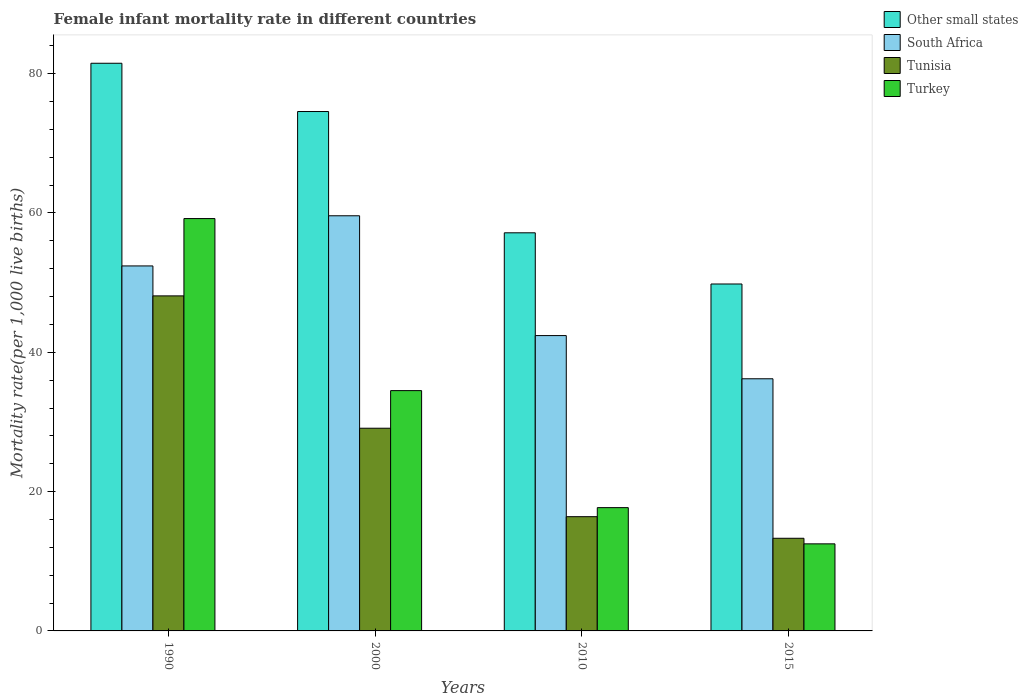How many different coloured bars are there?
Provide a succinct answer. 4. How many groups of bars are there?
Your response must be concise. 4. Are the number of bars on each tick of the X-axis equal?
Your answer should be compact. Yes. How many bars are there on the 3rd tick from the right?
Keep it short and to the point. 4. What is the female infant mortality rate in South Africa in 2015?
Keep it short and to the point. 36.2. Across all years, what is the maximum female infant mortality rate in Other small states?
Your answer should be compact. 81.5. Across all years, what is the minimum female infant mortality rate in South Africa?
Your answer should be very brief. 36.2. In which year was the female infant mortality rate in South Africa maximum?
Provide a succinct answer. 2000. In which year was the female infant mortality rate in South Africa minimum?
Your response must be concise. 2015. What is the total female infant mortality rate in Turkey in the graph?
Your response must be concise. 123.9. What is the difference between the female infant mortality rate in South Africa in 2000 and that in 2015?
Give a very brief answer. 23.4. What is the difference between the female infant mortality rate in South Africa in 2010 and the female infant mortality rate in Turkey in 2015?
Your answer should be compact. 29.9. What is the average female infant mortality rate in Other small states per year?
Make the answer very short. 65.76. In the year 2010, what is the difference between the female infant mortality rate in Turkey and female infant mortality rate in South Africa?
Offer a terse response. -24.7. What is the ratio of the female infant mortality rate in Other small states in 2010 to that in 2015?
Make the answer very short. 1.15. Is the female infant mortality rate in South Africa in 2000 less than that in 2010?
Offer a very short reply. No. What is the difference between the highest and the second highest female infant mortality rate in South Africa?
Offer a terse response. 7.2. What is the difference between the highest and the lowest female infant mortality rate in Tunisia?
Offer a terse response. 34.8. Is it the case that in every year, the sum of the female infant mortality rate in Other small states and female infant mortality rate in Tunisia is greater than the sum of female infant mortality rate in South Africa and female infant mortality rate in Turkey?
Provide a short and direct response. No. What does the 2nd bar from the left in 2015 represents?
Give a very brief answer. South Africa. What does the 1st bar from the right in 1990 represents?
Provide a short and direct response. Turkey. Is it the case that in every year, the sum of the female infant mortality rate in South Africa and female infant mortality rate in Other small states is greater than the female infant mortality rate in Turkey?
Your response must be concise. Yes. How many bars are there?
Provide a short and direct response. 16. Are all the bars in the graph horizontal?
Your answer should be very brief. No. How many years are there in the graph?
Keep it short and to the point. 4. Does the graph contain grids?
Provide a succinct answer. No. Where does the legend appear in the graph?
Provide a short and direct response. Top right. What is the title of the graph?
Provide a short and direct response. Female infant mortality rate in different countries. Does "Thailand" appear as one of the legend labels in the graph?
Give a very brief answer. No. What is the label or title of the Y-axis?
Offer a very short reply. Mortality rate(per 1,0 live births). What is the Mortality rate(per 1,000 live births) in Other small states in 1990?
Your answer should be compact. 81.5. What is the Mortality rate(per 1,000 live births) of South Africa in 1990?
Provide a succinct answer. 52.4. What is the Mortality rate(per 1,000 live births) in Tunisia in 1990?
Keep it short and to the point. 48.1. What is the Mortality rate(per 1,000 live births) of Turkey in 1990?
Provide a short and direct response. 59.2. What is the Mortality rate(per 1,000 live births) in Other small states in 2000?
Provide a short and direct response. 74.57. What is the Mortality rate(per 1,000 live births) of South Africa in 2000?
Provide a succinct answer. 59.6. What is the Mortality rate(per 1,000 live births) of Tunisia in 2000?
Give a very brief answer. 29.1. What is the Mortality rate(per 1,000 live births) in Turkey in 2000?
Provide a short and direct response. 34.5. What is the Mortality rate(per 1,000 live births) in Other small states in 2010?
Provide a succinct answer. 57.16. What is the Mortality rate(per 1,000 live births) of South Africa in 2010?
Your response must be concise. 42.4. What is the Mortality rate(per 1,000 live births) in Tunisia in 2010?
Provide a succinct answer. 16.4. What is the Mortality rate(per 1,000 live births) of Other small states in 2015?
Provide a succinct answer. 49.81. What is the Mortality rate(per 1,000 live births) of South Africa in 2015?
Provide a succinct answer. 36.2. What is the Mortality rate(per 1,000 live births) of Turkey in 2015?
Offer a terse response. 12.5. Across all years, what is the maximum Mortality rate(per 1,000 live births) of Other small states?
Your response must be concise. 81.5. Across all years, what is the maximum Mortality rate(per 1,000 live births) of South Africa?
Offer a terse response. 59.6. Across all years, what is the maximum Mortality rate(per 1,000 live births) of Tunisia?
Your answer should be compact. 48.1. Across all years, what is the maximum Mortality rate(per 1,000 live births) of Turkey?
Your answer should be compact. 59.2. Across all years, what is the minimum Mortality rate(per 1,000 live births) in Other small states?
Give a very brief answer. 49.81. Across all years, what is the minimum Mortality rate(per 1,000 live births) of South Africa?
Ensure brevity in your answer.  36.2. Across all years, what is the minimum Mortality rate(per 1,000 live births) in Tunisia?
Keep it short and to the point. 13.3. Across all years, what is the minimum Mortality rate(per 1,000 live births) of Turkey?
Your answer should be very brief. 12.5. What is the total Mortality rate(per 1,000 live births) of Other small states in the graph?
Offer a very short reply. 263.03. What is the total Mortality rate(per 1,000 live births) of South Africa in the graph?
Give a very brief answer. 190.6. What is the total Mortality rate(per 1,000 live births) in Tunisia in the graph?
Provide a short and direct response. 106.9. What is the total Mortality rate(per 1,000 live births) in Turkey in the graph?
Make the answer very short. 123.9. What is the difference between the Mortality rate(per 1,000 live births) in Other small states in 1990 and that in 2000?
Give a very brief answer. 6.93. What is the difference between the Mortality rate(per 1,000 live births) of Tunisia in 1990 and that in 2000?
Give a very brief answer. 19. What is the difference between the Mortality rate(per 1,000 live births) in Turkey in 1990 and that in 2000?
Your response must be concise. 24.7. What is the difference between the Mortality rate(per 1,000 live births) in Other small states in 1990 and that in 2010?
Offer a very short reply. 24.34. What is the difference between the Mortality rate(per 1,000 live births) in South Africa in 1990 and that in 2010?
Your response must be concise. 10. What is the difference between the Mortality rate(per 1,000 live births) of Tunisia in 1990 and that in 2010?
Ensure brevity in your answer.  31.7. What is the difference between the Mortality rate(per 1,000 live births) in Turkey in 1990 and that in 2010?
Make the answer very short. 41.5. What is the difference between the Mortality rate(per 1,000 live births) in Other small states in 1990 and that in 2015?
Give a very brief answer. 31.69. What is the difference between the Mortality rate(per 1,000 live births) in South Africa in 1990 and that in 2015?
Provide a short and direct response. 16.2. What is the difference between the Mortality rate(per 1,000 live births) in Tunisia in 1990 and that in 2015?
Keep it short and to the point. 34.8. What is the difference between the Mortality rate(per 1,000 live births) in Turkey in 1990 and that in 2015?
Your answer should be very brief. 46.7. What is the difference between the Mortality rate(per 1,000 live births) in Other small states in 2000 and that in 2010?
Give a very brief answer. 17.41. What is the difference between the Mortality rate(per 1,000 live births) in South Africa in 2000 and that in 2010?
Provide a succinct answer. 17.2. What is the difference between the Mortality rate(per 1,000 live births) of Tunisia in 2000 and that in 2010?
Your answer should be compact. 12.7. What is the difference between the Mortality rate(per 1,000 live births) of Turkey in 2000 and that in 2010?
Ensure brevity in your answer.  16.8. What is the difference between the Mortality rate(per 1,000 live births) in Other small states in 2000 and that in 2015?
Your answer should be compact. 24.76. What is the difference between the Mortality rate(per 1,000 live births) of South Africa in 2000 and that in 2015?
Ensure brevity in your answer.  23.4. What is the difference between the Mortality rate(per 1,000 live births) in Turkey in 2000 and that in 2015?
Your answer should be very brief. 22. What is the difference between the Mortality rate(per 1,000 live births) of Other small states in 2010 and that in 2015?
Provide a short and direct response. 7.35. What is the difference between the Mortality rate(per 1,000 live births) in Other small states in 1990 and the Mortality rate(per 1,000 live births) in South Africa in 2000?
Give a very brief answer. 21.9. What is the difference between the Mortality rate(per 1,000 live births) in Other small states in 1990 and the Mortality rate(per 1,000 live births) in Tunisia in 2000?
Offer a very short reply. 52.4. What is the difference between the Mortality rate(per 1,000 live births) in Other small states in 1990 and the Mortality rate(per 1,000 live births) in Turkey in 2000?
Provide a succinct answer. 47. What is the difference between the Mortality rate(per 1,000 live births) of South Africa in 1990 and the Mortality rate(per 1,000 live births) of Tunisia in 2000?
Your response must be concise. 23.3. What is the difference between the Mortality rate(per 1,000 live births) in Tunisia in 1990 and the Mortality rate(per 1,000 live births) in Turkey in 2000?
Make the answer very short. 13.6. What is the difference between the Mortality rate(per 1,000 live births) of Other small states in 1990 and the Mortality rate(per 1,000 live births) of South Africa in 2010?
Keep it short and to the point. 39.1. What is the difference between the Mortality rate(per 1,000 live births) in Other small states in 1990 and the Mortality rate(per 1,000 live births) in Tunisia in 2010?
Give a very brief answer. 65.1. What is the difference between the Mortality rate(per 1,000 live births) of Other small states in 1990 and the Mortality rate(per 1,000 live births) of Turkey in 2010?
Your answer should be very brief. 63.8. What is the difference between the Mortality rate(per 1,000 live births) of South Africa in 1990 and the Mortality rate(per 1,000 live births) of Turkey in 2010?
Make the answer very short. 34.7. What is the difference between the Mortality rate(per 1,000 live births) of Tunisia in 1990 and the Mortality rate(per 1,000 live births) of Turkey in 2010?
Keep it short and to the point. 30.4. What is the difference between the Mortality rate(per 1,000 live births) in Other small states in 1990 and the Mortality rate(per 1,000 live births) in South Africa in 2015?
Provide a succinct answer. 45.3. What is the difference between the Mortality rate(per 1,000 live births) of Other small states in 1990 and the Mortality rate(per 1,000 live births) of Tunisia in 2015?
Ensure brevity in your answer.  68.2. What is the difference between the Mortality rate(per 1,000 live births) in Other small states in 1990 and the Mortality rate(per 1,000 live births) in Turkey in 2015?
Your response must be concise. 69. What is the difference between the Mortality rate(per 1,000 live births) in South Africa in 1990 and the Mortality rate(per 1,000 live births) in Tunisia in 2015?
Offer a terse response. 39.1. What is the difference between the Mortality rate(per 1,000 live births) in South Africa in 1990 and the Mortality rate(per 1,000 live births) in Turkey in 2015?
Offer a terse response. 39.9. What is the difference between the Mortality rate(per 1,000 live births) in Tunisia in 1990 and the Mortality rate(per 1,000 live births) in Turkey in 2015?
Your answer should be very brief. 35.6. What is the difference between the Mortality rate(per 1,000 live births) of Other small states in 2000 and the Mortality rate(per 1,000 live births) of South Africa in 2010?
Ensure brevity in your answer.  32.17. What is the difference between the Mortality rate(per 1,000 live births) in Other small states in 2000 and the Mortality rate(per 1,000 live births) in Tunisia in 2010?
Give a very brief answer. 58.17. What is the difference between the Mortality rate(per 1,000 live births) in Other small states in 2000 and the Mortality rate(per 1,000 live births) in Turkey in 2010?
Ensure brevity in your answer.  56.87. What is the difference between the Mortality rate(per 1,000 live births) in South Africa in 2000 and the Mortality rate(per 1,000 live births) in Tunisia in 2010?
Provide a short and direct response. 43.2. What is the difference between the Mortality rate(per 1,000 live births) in South Africa in 2000 and the Mortality rate(per 1,000 live births) in Turkey in 2010?
Offer a terse response. 41.9. What is the difference between the Mortality rate(per 1,000 live births) of Other small states in 2000 and the Mortality rate(per 1,000 live births) of South Africa in 2015?
Offer a terse response. 38.37. What is the difference between the Mortality rate(per 1,000 live births) of Other small states in 2000 and the Mortality rate(per 1,000 live births) of Tunisia in 2015?
Your response must be concise. 61.27. What is the difference between the Mortality rate(per 1,000 live births) of Other small states in 2000 and the Mortality rate(per 1,000 live births) of Turkey in 2015?
Make the answer very short. 62.07. What is the difference between the Mortality rate(per 1,000 live births) in South Africa in 2000 and the Mortality rate(per 1,000 live births) in Tunisia in 2015?
Offer a terse response. 46.3. What is the difference between the Mortality rate(per 1,000 live births) in South Africa in 2000 and the Mortality rate(per 1,000 live births) in Turkey in 2015?
Your response must be concise. 47.1. What is the difference between the Mortality rate(per 1,000 live births) of Tunisia in 2000 and the Mortality rate(per 1,000 live births) of Turkey in 2015?
Your answer should be very brief. 16.6. What is the difference between the Mortality rate(per 1,000 live births) of Other small states in 2010 and the Mortality rate(per 1,000 live births) of South Africa in 2015?
Offer a very short reply. 20.96. What is the difference between the Mortality rate(per 1,000 live births) of Other small states in 2010 and the Mortality rate(per 1,000 live births) of Tunisia in 2015?
Keep it short and to the point. 43.86. What is the difference between the Mortality rate(per 1,000 live births) of Other small states in 2010 and the Mortality rate(per 1,000 live births) of Turkey in 2015?
Your answer should be very brief. 44.66. What is the difference between the Mortality rate(per 1,000 live births) in South Africa in 2010 and the Mortality rate(per 1,000 live births) in Tunisia in 2015?
Your answer should be compact. 29.1. What is the difference between the Mortality rate(per 1,000 live births) of South Africa in 2010 and the Mortality rate(per 1,000 live births) of Turkey in 2015?
Your response must be concise. 29.9. What is the average Mortality rate(per 1,000 live births) in Other small states per year?
Give a very brief answer. 65.76. What is the average Mortality rate(per 1,000 live births) in South Africa per year?
Provide a succinct answer. 47.65. What is the average Mortality rate(per 1,000 live births) of Tunisia per year?
Your answer should be compact. 26.73. What is the average Mortality rate(per 1,000 live births) in Turkey per year?
Keep it short and to the point. 30.98. In the year 1990, what is the difference between the Mortality rate(per 1,000 live births) in Other small states and Mortality rate(per 1,000 live births) in South Africa?
Make the answer very short. 29.1. In the year 1990, what is the difference between the Mortality rate(per 1,000 live births) of Other small states and Mortality rate(per 1,000 live births) of Tunisia?
Your answer should be very brief. 33.4. In the year 1990, what is the difference between the Mortality rate(per 1,000 live births) in Other small states and Mortality rate(per 1,000 live births) in Turkey?
Give a very brief answer. 22.3. In the year 1990, what is the difference between the Mortality rate(per 1,000 live births) in South Africa and Mortality rate(per 1,000 live births) in Tunisia?
Offer a terse response. 4.3. In the year 1990, what is the difference between the Mortality rate(per 1,000 live births) of South Africa and Mortality rate(per 1,000 live births) of Turkey?
Provide a short and direct response. -6.8. In the year 2000, what is the difference between the Mortality rate(per 1,000 live births) of Other small states and Mortality rate(per 1,000 live births) of South Africa?
Keep it short and to the point. 14.97. In the year 2000, what is the difference between the Mortality rate(per 1,000 live births) in Other small states and Mortality rate(per 1,000 live births) in Tunisia?
Ensure brevity in your answer.  45.47. In the year 2000, what is the difference between the Mortality rate(per 1,000 live births) in Other small states and Mortality rate(per 1,000 live births) in Turkey?
Your response must be concise. 40.07. In the year 2000, what is the difference between the Mortality rate(per 1,000 live births) of South Africa and Mortality rate(per 1,000 live births) of Tunisia?
Give a very brief answer. 30.5. In the year 2000, what is the difference between the Mortality rate(per 1,000 live births) in South Africa and Mortality rate(per 1,000 live births) in Turkey?
Provide a succinct answer. 25.1. In the year 2000, what is the difference between the Mortality rate(per 1,000 live births) in Tunisia and Mortality rate(per 1,000 live births) in Turkey?
Provide a succinct answer. -5.4. In the year 2010, what is the difference between the Mortality rate(per 1,000 live births) of Other small states and Mortality rate(per 1,000 live births) of South Africa?
Offer a terse response. 14.76. In the year 2010, what is the difference between the Mortality rate(per 1,000 live births) of Other small states and Mortality rate(per 1,000 live births) of Tunisia?
Give a very brief answer. 40.76. In the year 2010, what is the difference between the Mortality rate(per 1,000 live births) in Other small states and Mortality rate(per 1,000 live births) in Turkey?
Your answer should be very brief. 39.46. In the year 2010, what is the difference between the Mortality rate(per 1,000 live births) in South Africa and Mortality rate(per 1,000 live births) in Turkey?
Provide a succinct answer. 24.7. In the year 2015, what is the difference between the Mortality rate(per 1,000 live births) in Other small states and Mortality rate(per 1,000 live births) in South Africa?
Offer a terse response. 13.61. In the year 2015, what is the difference between the Mortality rate(per 1,000 live births) in Other small states and Mortality rate(per 1,000 live births) in Tunisia?
Offer a terse response. 36.51. In the year 2015, what is the difference between the Mortality rate(per 1,000 live births) in Other small states and Mortality rate(per 1,000 live births) in Turkey?
Provide a short and direct response. 37.31. In the year 2015, what is the difference between the Mortality rate(per 1,000 live births) of South Africa and Mortality rate(per 1,000 live births) of Tunisia?
Offer a terse response. 22.9. In the year 2015, what is the difference between the Mortality rate(per 1,000 live births) in South Africa and Mortality rate(per 1,000 live births) in Turkey?
Provide a short and direct response. 23.7. In the year 2015, what is the difference between the Mortality rate(per 1,000 live births) in Tunisia and Mortality rate(per 1,000 live births) in Turkey?
Make the answer very short. 0.8. What is the ratio of the Mortality rate(per 1,000 live births) in Other small states in 1990 to that in 2000?
Your answer should be very brief. 1.09. What is the ratio of the Mortality rate(per 1,000 live births) in South Africa in 1990 to that in 2000?
Keep it short and to the point. 0.88. What is the ratio of the Mortality rate(per 1,000 live births) in Tunisia in 1990 to that in 2000?
Offer a terse response. 1.65. What is the ratio of the Mortality rate(per 1,000 live births) in Turkey in 1990 to that in 2000?
Provide a succinct answer. 1.72. What is the ratio of the Mortality rate(per 1,000 live births) in Other small states in 1990 to that in 2010?
Make the answer very short. 1.43. What is the ratio of the Mortality rate(per 1,000 live births) in South Africa in 1990 to that in 2010?
Provide a short and direct response. 1.24. What is the ratio of the Mortality rate(per 1,000 live births) of Tunisia in 1990 to that in 2010?
Your answer should be very brief. 2.93. What is the ratio of the Mortality rate(per 1,000 live births) in Turkey in 1990 to that in 2010?
Keep it short and to the point. 3.34. What is the ratio of the Mortality rate(per 1,000 live births) of Other small states in 1990 to that in 2015?
Provide a short and direct response. 1.64. What is the ratio of the Mortality rate(per 1,000 live births) of South Africa in 1990 to that in 2015?
Your response must be concise. 1.45. What is the ratio of the Mortality rate(per 1,000 live births) of Tunisia in 1990 to that in 2015?
Ensure brevity in your answer.  3.62. What is the ratio of the Mortality rate(per 1,000 live births) of Turkey in 1990 to that in 2015?
Your answer should be compact. 4.74. What is the ratio of the Mortality rate(per 1,000 live births) of Other small states in 2000 to that in 2010?
Provide a short and direct response. 1.3. What is the ratio of the Mortality rate(per 1,000 live births) of South Africa in 2000 to that in 2010?
Your answer should be very brief. 1.41. What is the ratio of the Mortality rate(per 1,000 live births) of Tunisia in 2000 to that in 2010?
Your answer should be compact. 1.77. What is the ratio of the Mortality rate(per 1,000 live births) of Turkey in 2000 to that in 2010?
Offer a terse response. 1.95. What is the ratio of the Mortality rate(per 1,000 live births) of Other small states in 2000 to that in 2015?
Give a very brief answer. 1.5. What is the ratio of the Mortality rate(per 1,000 live births) in South Africa in 2000 to that in 2015?
Offer a very short reply. 1.65. What is the ratio of the Mortality rate(per 1,000 live births) in Tunisia in 2000 to that in 2015?
Your response must be concise. 2.19. What is the ratio of the Mortality rate(per 1,000 live births) of Turkey in 2000 to that in 2015?
Make the answer very short. 2.76. What is the ratio of the Mortality rate(per 1,000 live births) of Other small states in 2010 to that in 2015?
Your answer should be compact. 1.15. What is the ratio of the Mortality rate(per 1,000 live births) of South Africa in 2010 to that in 2015?
Your answer should be very brief. 1.17. What is the ratio of the Mortality rate(per 1,000 live births) of Tunisia in 2010 to that in 2015?
Your answer should be compact. 1.23. What is the ratio of the Mortality rate(per 1,000 live births) of Turkey in 2010 to that in 2015?
Provide a short and direct response. 1.42. What is the difference between the highest and the second highest Mortality rate(per 1,000 live births) in Other small states?
Provide a succinct answer. 6.93. What is the difference between the highest and the second highest Mortality rate(per 1,000 live births) in South Africa?
Ensure brevity in your answer.  7.2. What is the difference between the highest and the second highest Mortality rate(per 1,000 live births) in Tunisia?
Make the answer very short. 19. What is the difference between the highest and the second highest Mortality rate(per 1,000 live births) in Turkey?
Your answer should be compact. 24.7. What is the difference between the highest and the lowest Mortality rate(per 1,000 live births) in Other small states?
Provide a succinct answer. 31.69. What is the difference between the highest and the lowest Mortality rate(per 1,000 live births) of South Africa?
Your answer should be very brief. 23.4. What is the difference between the highest and the lowest Mortality rate(per 1,000 live births) of Tunisia?
Give a very brief answer. 34.8. What is the difference between the highest and the lowest Mortality rate(per 1,000 live births) of Turkey?
Give a very brief answer. 46.7. 